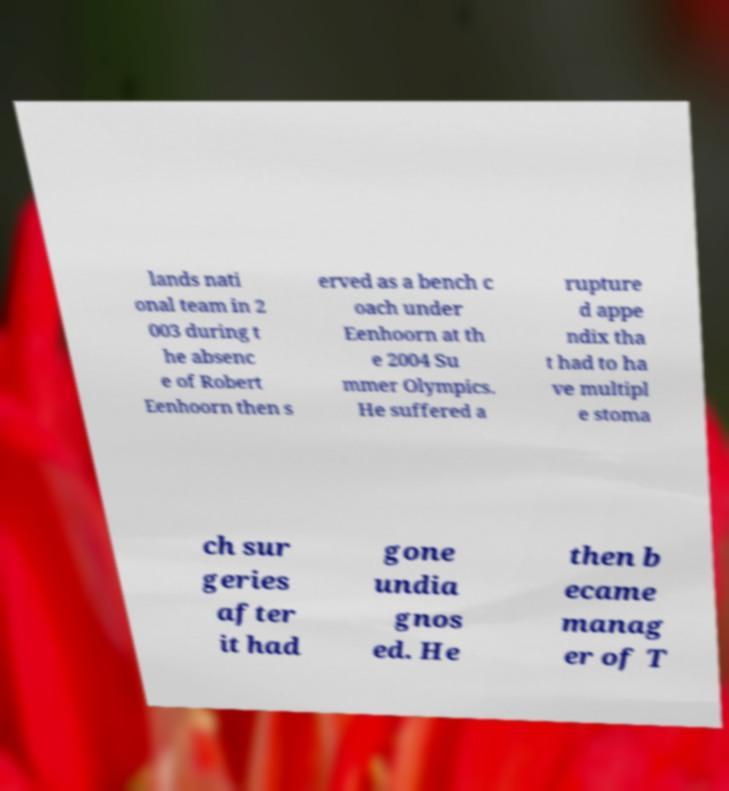Please identify and transcribe the text found in this image. lands nati onal team in 2 003 during t he absenc e of Robert Eenhoorn then s erved as a bench c oach under Eenhoorn at th e 2004 Su mmer Olympics. He suffered a rupture d appe ndix tha t had to ha ve multipl e stoma ch sur geries after it had gone undia gnos ed. He then b ecame manag er of T 